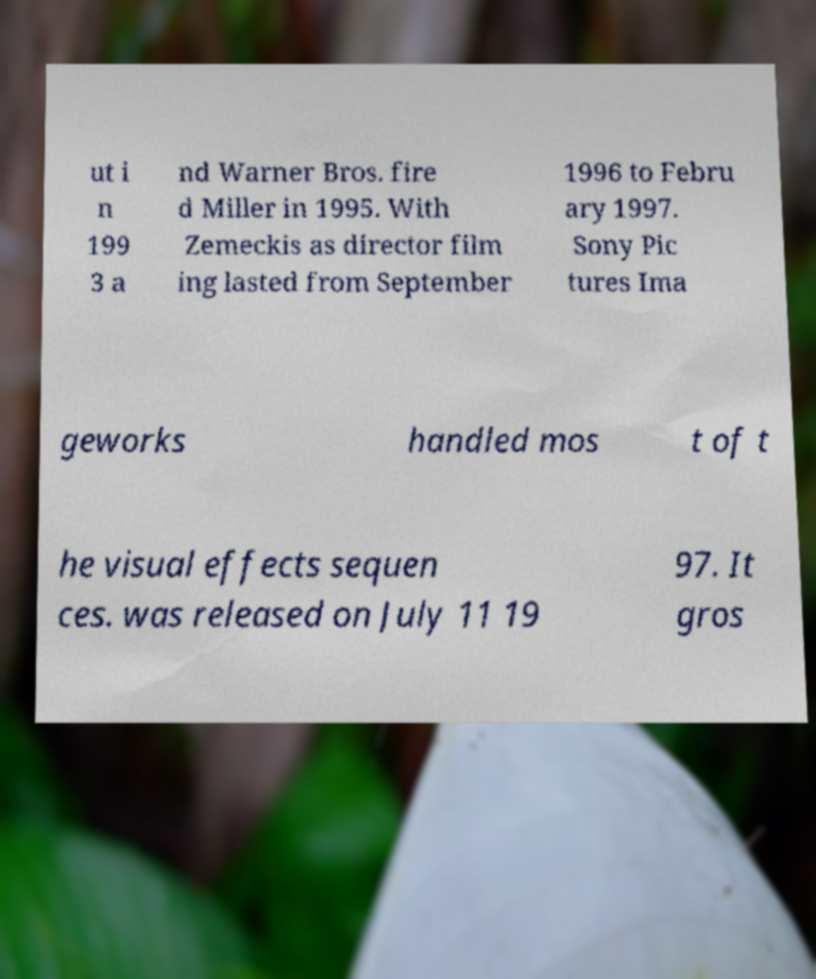Please identify and transcribe the text found in this image. ut i n 199 3 a nd Warner Bros. fire d Miller in 1995. With Zemeckis as director film ing lasted from September 1996 to Febru ary 1997. Sony Pic tures Ima geworks handled mos t of t he visual effects sequen ces. was released on July 11 19 97. It gros 